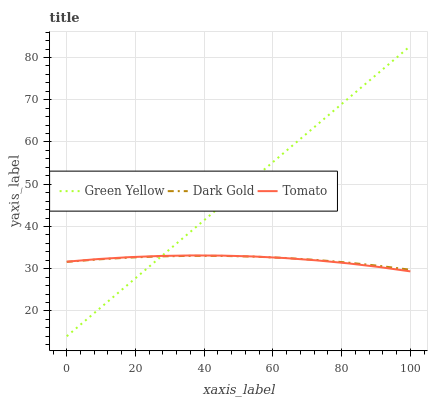Does Tomato have the minimum area under the curve?
Answer yes or no. Yes. Does Green Yellow have the maximum area under the curve?
Answer yes or no. Yes. Does Dark Gold have the minimum area under the curve?
Answer yes or no. No. Does Dark Gold have the maximum area under the curve?
Answer yes or no. No. Is Green Yellow the smoothest?
Answer yes or no. Yes. Is Tomato the roughest?
Answer yes or no. Yes. Is Dark Gold the smoothest?
Answer yes or no. No. Is Dark Gold the roughest?
Answer yes or no. No. Does Green Yellow have the lowest value?
Answer yes or no. Yes. Does Dark Gold have the lowest value?
Answer yes or no. No. Does Green Yellow have the highest value?
Answer yes or no. Yes. Does Dark Gold have the highest value?
Answer yes or no. No. Does Tomato intersect Dark Gold?
Answer yes or no. Yes. Is Tomato less than Dark Gold?
Answer yes or no. No. Is Tomato greater than Dark Gold?
Answer yes or no. No. 